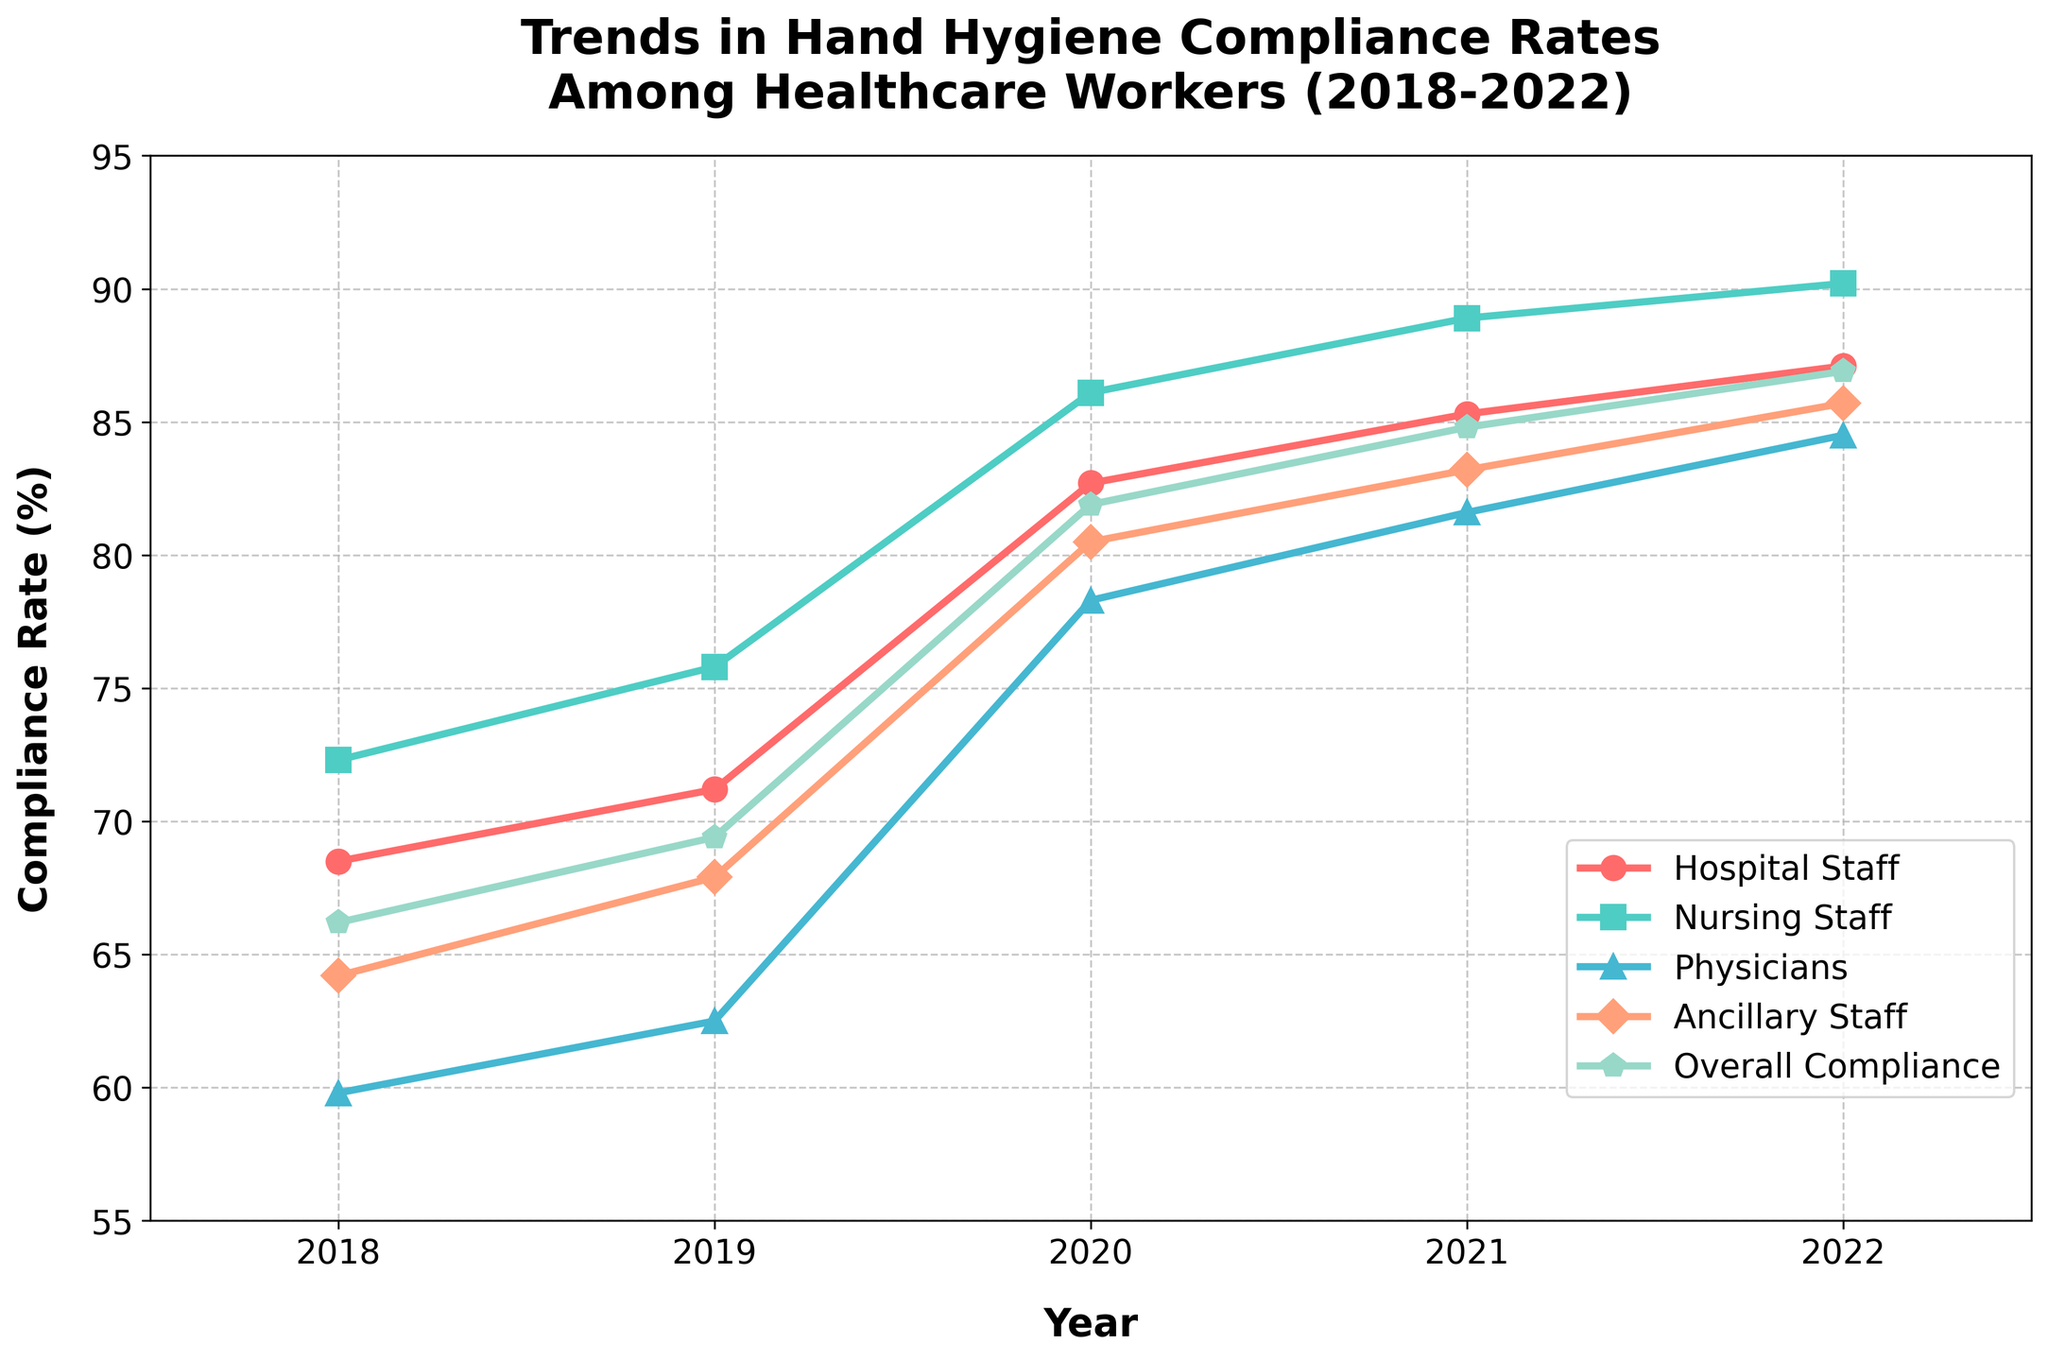What's the overall trend in hand hygiene compliance rates from 2018 to 2022? The overall trend can be observed by looking at the line for "Overall Compliance" from 2018 to 2022. The line shows a steady increase every year.
Answer: Increasing Which staff category showed the highest compliance rate in 2022? By examining the lines at the far right of the chart (for the year 2022), the "Nursing Staff" line is at the highest position, indicating the highest compliance rate in that year.
Answer: Nursing Staff In which year did "Physicians" see the most significant increase in compliance rates compared to the previous year? By comparing the difference in the "Physicians" line year by year, the largest jump is observed between 2019 (62.5) and 2020 (78.3), which is an increase of 15.8.
Answer: 2020 How does the compliance rate of "Ancillary Staff" in 2021 compare with that in 2018? The compliance rate for "Ancillary Staff" in 2021 is 83.2 and in 2018 it is 64.2. To find the difference, subtract the 2018 rate from the 2021 rate: 83.2 - 64.2 = 19.
Answer: 19 What is the average compliance rate for "Hospital Staff" over the 5-year period? To find the average, sum the compliance rates for "Hospital Staff" over the 5 years (68.5, 71.2, 82.7, 85.3, 87.1) and divide by 5: (68.5 + 71.2 + 82.7 + 85.3 + 87.1) / 5 = 78.96.
Answer: 78.96 Which year had the lowest overall compliance rate and what was it? By looking at the "Overall Compliance" line, the lowest point is in 2018, with a compliance rate of 66.2%.
Answer: 2018 Did the compliance rate for "Nursing Staff" ever decrease over the 5-year period? By observing the "Nursing Staff" line from 2018 to 2022, the compliance rate increases every year without any decreases.
Answer: No What is the difference in compliance rates between "Hospital Staff" and "Physicians" in 2022? The compliance rate for "Hospital Staff" in 2022 is 87.1, and for "Physicians" it is 84.5. To find the difference, subtract the "Physicians" rate from the "Hospital Staff" rate: 87.1 - 84.5 = 2.6.
Answer: 2.6 Which two staff categories have the closest compliance rates in 2020? By looking at the lines for the year 2020, "Hospital Staff" (82.7) and "Ancillary Staff" (80.5) have the closest compliance rates with a difference of only 2.2.
Answer: Hospital Staff and Ancillary Staff What percentage increase in "Overall Compliance" can be observed from 2018 to 2022? To find the percentage increase, subtract the 2018 rate from the 2022 rate and divide by the 2018 rate, then multiply by 100: ((86.9 - 66.2) / 66.2) * 100 ≈ 31.2%.
Answer: 31.2% 